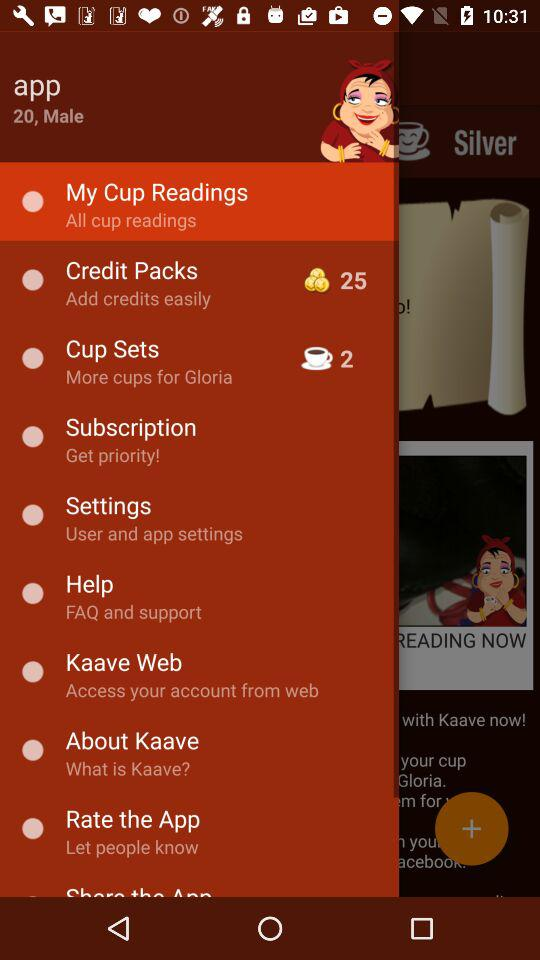How many cup sets are available? There are 2 cup sets available. 